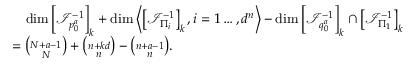Convert formula to latex. <formula><loc_0><loc_0><loc_500><loc_500>\begin{array} { r l } & { \quad \dim \left [ \mathcal { I } _ { p _ { 0 } ^ { a } } ^ { - 1 } \right ] _ { k } + \dim \left \langle \left [ \mathcal { I } _ { \Pi _ { i } } ^ { - 1 } \right ] _ { k } , i = 1 \dots , d ^ { n } \right \rangle - \dim \left [ \mathcal { I } _ { q _ { 0 } ^ { a } } ^ { - 1 } \right ] _ { k } \cap \left [ \mathcal { I } _ { \Pi _ { 1 } } ^ { - 1 } \right ] _ { k } } \\ & { = { \binom { N + a - 1 } { N } } + { \binom { n + k d } { n } } - { \binom { n + a - 1 } { n } } . } \end{array}</formula> 